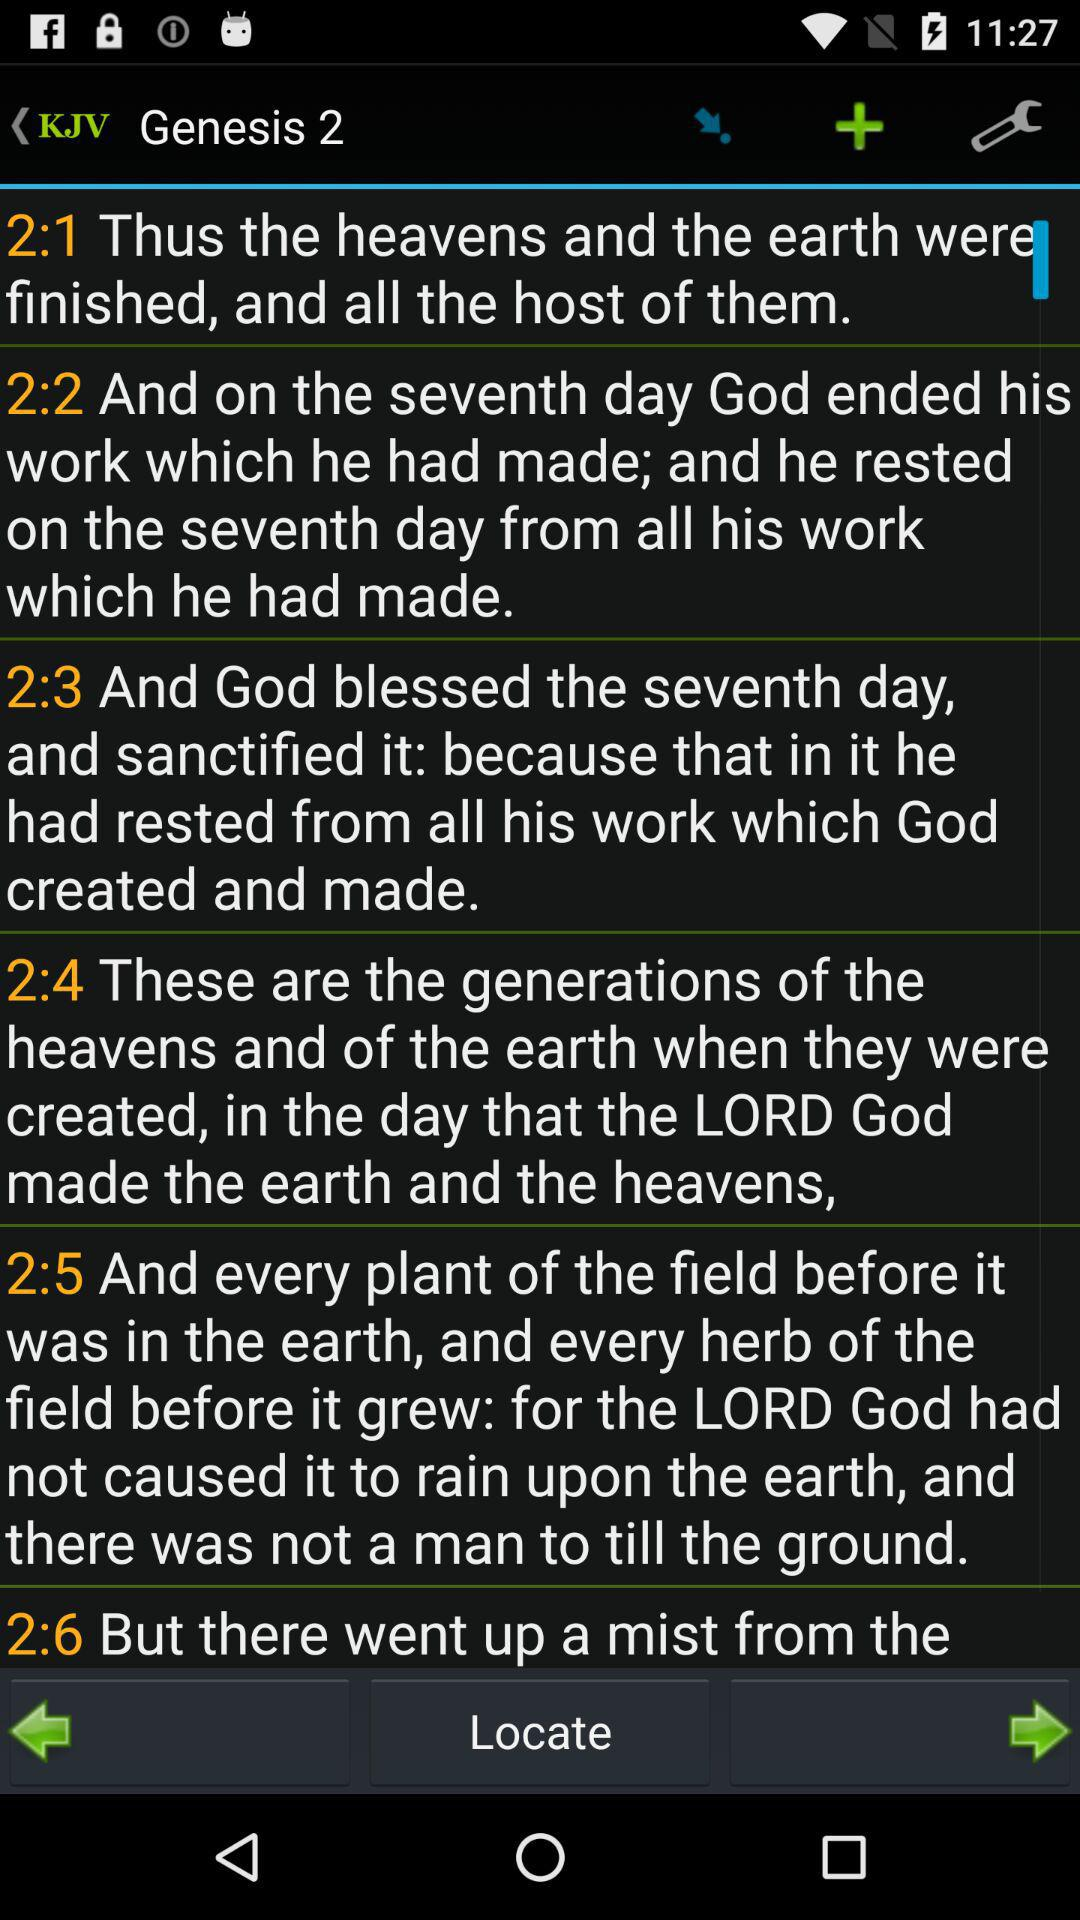On what day did God end his work? God ended his work on the seventh day. 